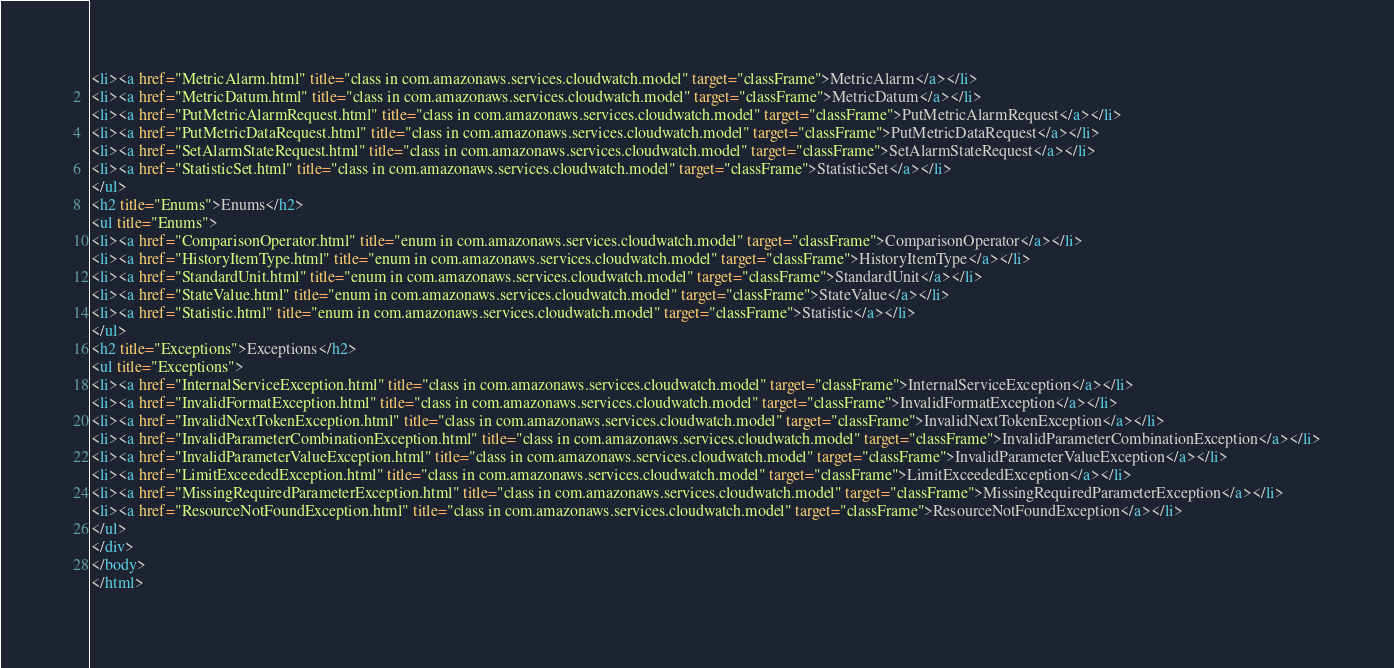Convert code to text. <code><loc_0><loc_0><loc_500><loc_500><_HTML_><li><a href="MetricAlarm.html" title="class in com.amazonaws.services.cloudwatch.model" target="classFrame">MetricAlarm</a></li>
<li><a href="MetricDatum.html" title="class in com.amazonaws.services.cloudwatch.model" target="classFrame">MetricDatum</a></li>
<li><a href="PutMetricAlarmRequest.html" title="class in com.amazonaws.services.cloudwatch.model" target="classFrame">PutMetricAlarmRequest</a></li>
<li><a href="PutMetricDataRequest.html" title="class in com.amazonaws.services.cloudwatch.model" target="classFrame">PutMetricDataRequest</a></li>
<li><a href="SetAlarmStateRequest.html" title="class in com.amazonaws.services.cloudwatch.model" target="classFrame">SetAlarmStateRequest</a></li>
<li><a href="StatisticSet.html" title="class in com.amazonaws.services.cloudwatch.model" target="classFrame">StatisticSet</a></li>
</ul>
<h2 title="Enums">Enums</h2>
<ul title="Enums">
<li><a href="ComparisonOperator.html" title="enum in com.amazonaws.services.cloudwatch.model" target="classFrame">ComparisonOperator</a></li>
<li><a href="HistoryItemType.html" title="enum in com.amazonaws.services.cloudwatch.model" target="classFrame">HistoryItemType</a></li>
<li><a href="StandardUnit.html" title="enum in com.amazonaws.services.cloudwatch.model" target="classFrame">StandardUnit</a></li>
<li><a href="StateValue.html" title="enum in com.amazonaws.services.cloudwatch.model" target="classFrame">StateValue</a></li>
<li><a href="Statistic.html" title="enum in com.amazonaws.services.cloudwatch.model" target="classFrame">Statistic</a></li>
</ul>
<h2 title="Exceptions">Exceptions</h2>
<ul title="Exceptions">
<li><a href="InternalServiceException.html" title="class in com.amazonaws.services.cloudwatch.model" target="classFrame">InternalServiceException</a></li>
<li><a href="InvalidFormatException.html" title="class in com.amazonaws.services.cloudwatch.model" target="classFrame">InvalidFormatException</a></li>
<li><a href="InvalidNextTokenException.html" title="class in com.amazonaws.services.cloudwatch.model" target="classFrame">InvalidNextTokenException</a></li>
<li><a href="InvalidParameterCombinationException.html" title="class in com.amazonaws.services.cloudwatch.model" target="classFrame">InvalidParameterCombinationException</a></li>
<li><a href="InvalidParameterValueException.html" title="class in com.amazonaws.services.cloudwatch.model" target="classFrame">InvalidParameterValueException</a></li>
<li><a href="LimitExceededException.html" title="class in com.amazonaws.services.cloudwatch.model" target="classFrame">LimitExceededException</a></li>
<li><a href="MissingRequiredParameterException.html" title="class in com.amazonaws.services.cloudwatch.model" target="classFrame">MissingRequiredParameterException</a></li>
<li><a href="ResourceNotFoundException.html" title="class in com.amazonaws.services.cloudwatch.model" target="classFrame">ResourceNotFoundException</a></li>
</ul>
</div>
</body>
</html>
</code> 